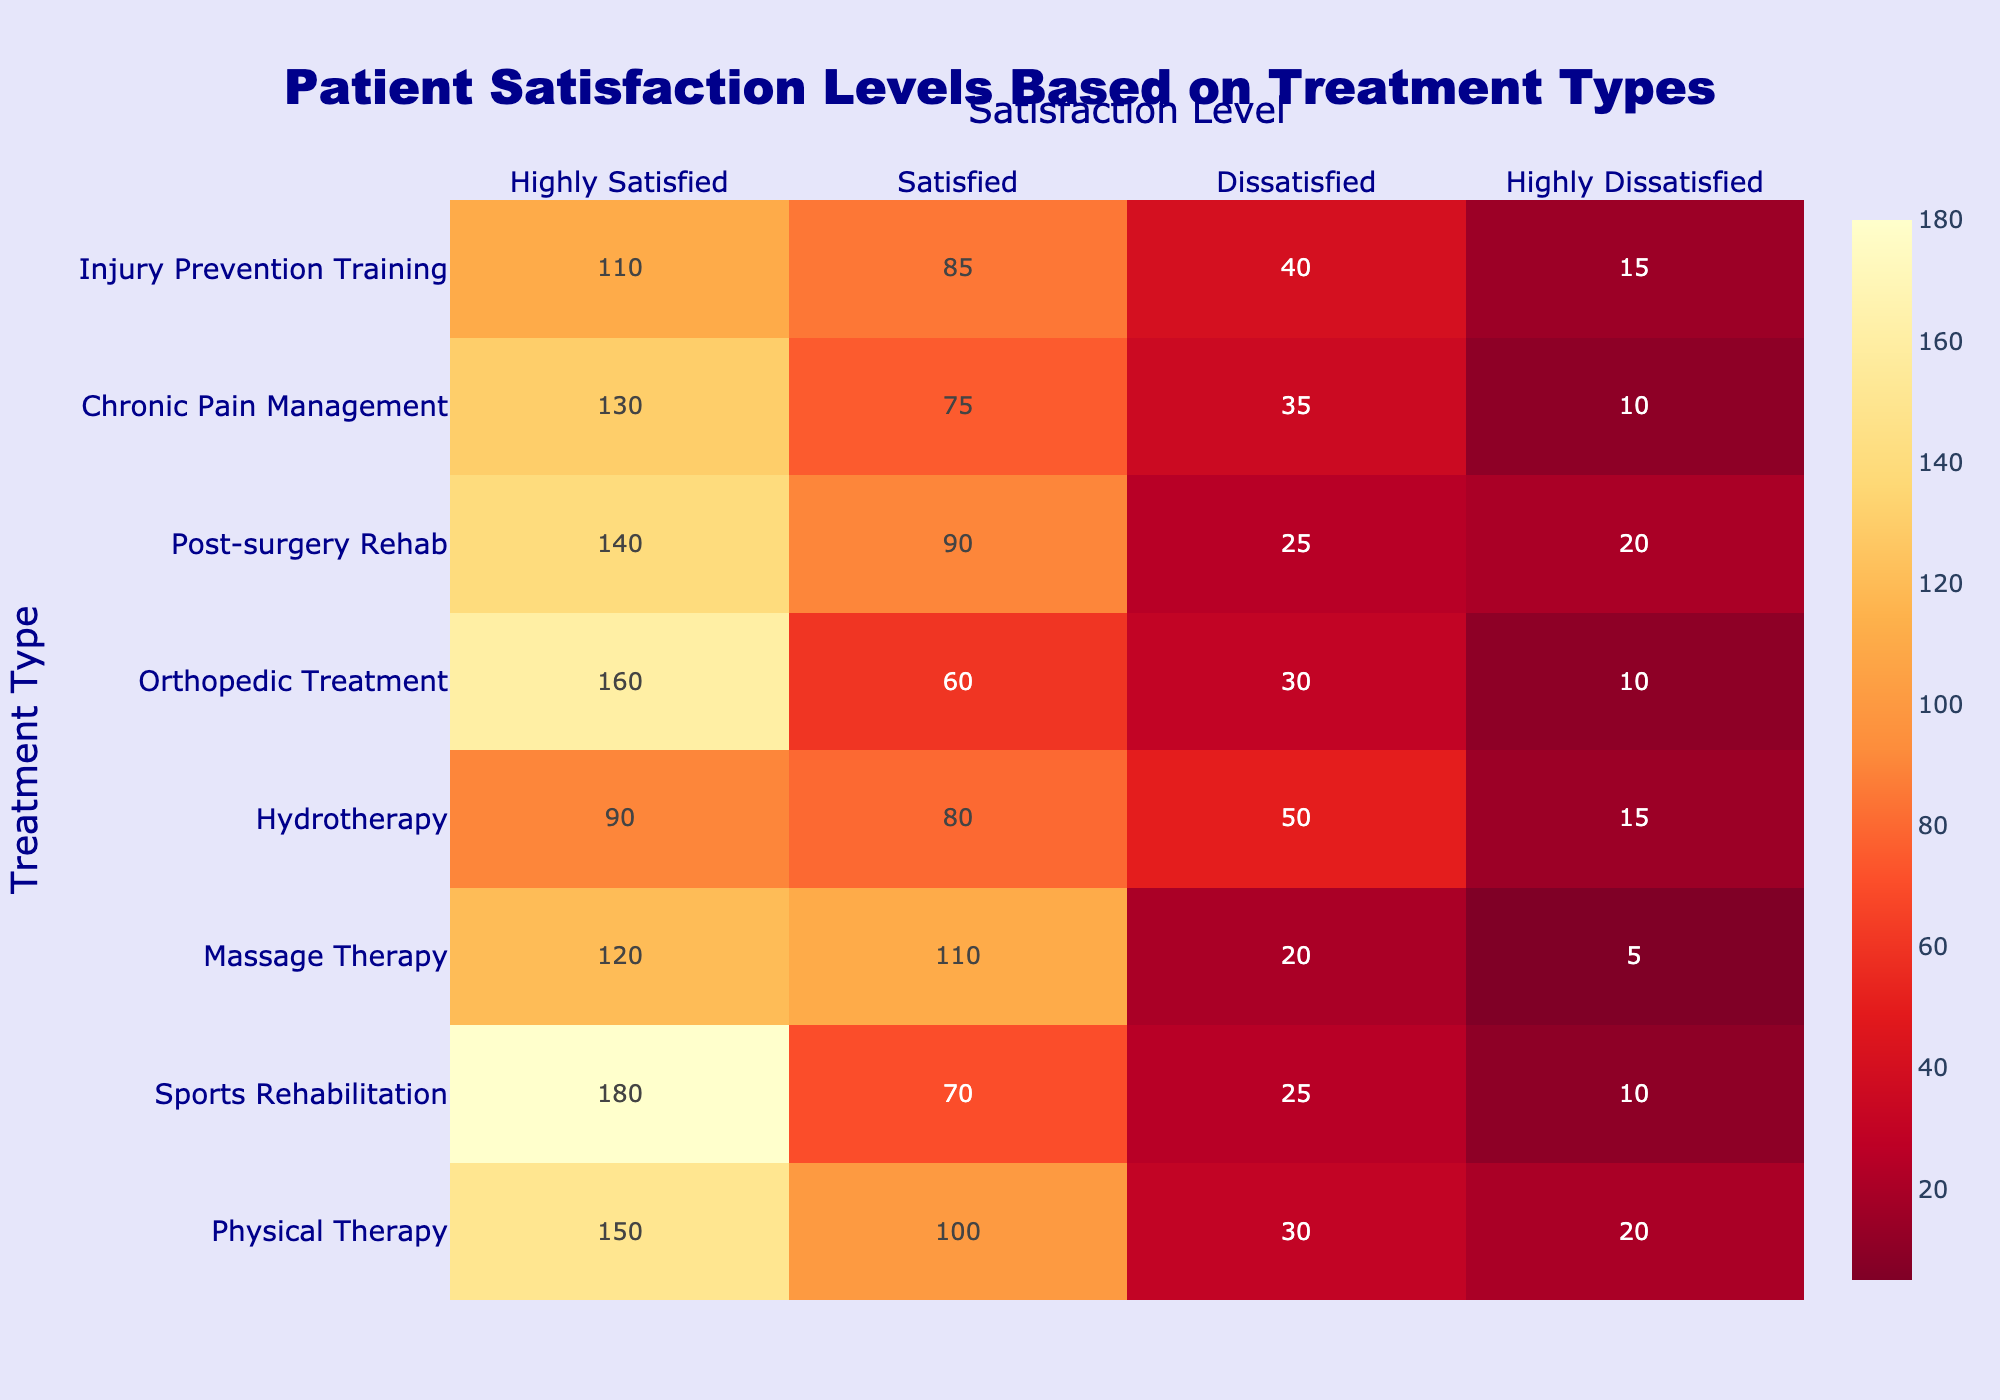What treatment type has the highest number of highly satisfied patients? By examining the "Highly Satisfied" column, we identify the values for each treatment type. The highest value is 180, which corresponds to Sports Rehabilitation.
Answer: Sports Rehabilitation What is the total number of dissatisfied patients across all treatment types? To find the total number of dissatisfied patients, we sum the number of dissatisfied patients from each treatment type: 30 + 25 + 20 + 50 + 30 + 25 + 35 + 40 = 255.
Answer: 255 Is there any treatment type with more highly satisfied patients than dissatisfied patients? For each treatment type, we compare the number of highly satisfied patients versus dissatisfied patients. All treatment types have a higher number of highly satisfied patients when compared with dissatisfied patients.
Answer: Yes Which treatment type has the lowest number of total satisfied patients? We first sum the "Satisfied," "Dissatisfied," and "Highly Dissatisfied" values for each treatment type. Hydrotherapy has 80 + 50 + 15 = 145, which is the lowest total satisfied patients among all.
Answer: Hydrotherapy What is the average number of highly satisfied patients for the listed treatment types? We sum the highly satisfied patients: 150 + 180 + 120 + 90 + 160 + 140 + 130 + 110 = 1080. There are 8 treatment types, so the average is 1080 / 8 = 135.
Answer: 135 Which treatment type has the highest dissatisfaction rate? To determine the highest dissatisfaction rate, we need to calculate the percentage of dissatisfied patients for each treatment type against the total number of respondents. Hydrotherapy has (50 + 15) / (90 + 80 + 50 + 15) = 65 / 185 ≈ 35.14%, which is the highest rate.
Answer: Hydrotherapy What is the difference in the number of highly satisfied patients between Physical Therapy and Massage Therapy? We find the number of highly satisfied patients for each: Physical Therapy has 150 and Massage Therapy has 120. The difference is 150 - 120 = 30.
Answer: 30 Which treatment type has the largest gap between highly satisfied and highly dissatisfied patients? The gap can be calculated by taking the difference between highly satisfied and highly dissatisfied for each type. Sports Rehabilitation has 180 - 10 = 170, which is the largest gap among treatments.
Answer: Sports Rehabilitation 